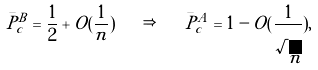<formula> <loc_0><loc_0><loc_500><loc_500>\bar { P } ^ { B } _ { c } = \frac { 1 } { 2 } + O ( \frac { 1 } { n } ) \quad \Rightarrow \quad \bar { P } ^ { A } _ { c } = 1 - O ( \frac { 1 } { \sqrt { n } } ) ,</formula> 